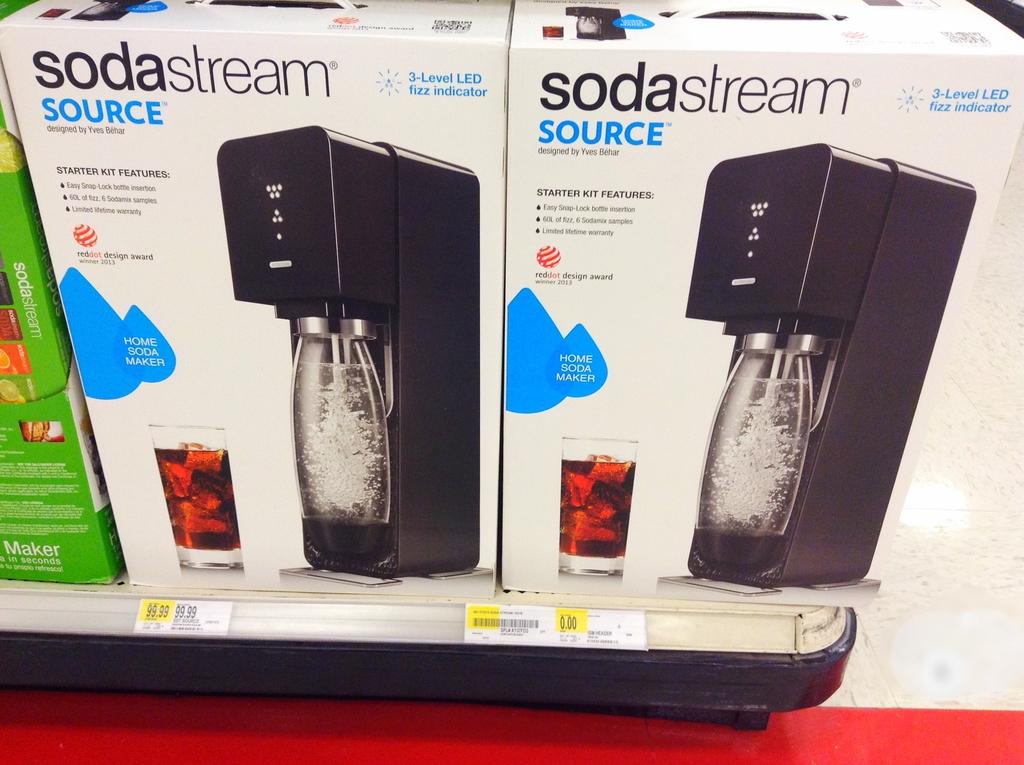How many levels are there to the led fizz indicator?
Provide a short and direct response. 3. How much soda comes with this package?
Offer a very short reply. 60l. 